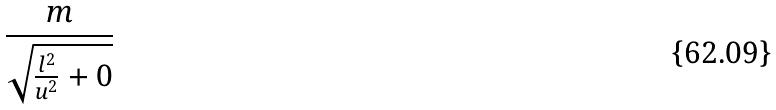Convert formula to latex. <formula><loc_0><loc_0><loc_500><loc_500>\frac { m } { \sqrt { \frac { l ^ { 2 } } { u ^ { 2 } } + 0 } }</formula> 